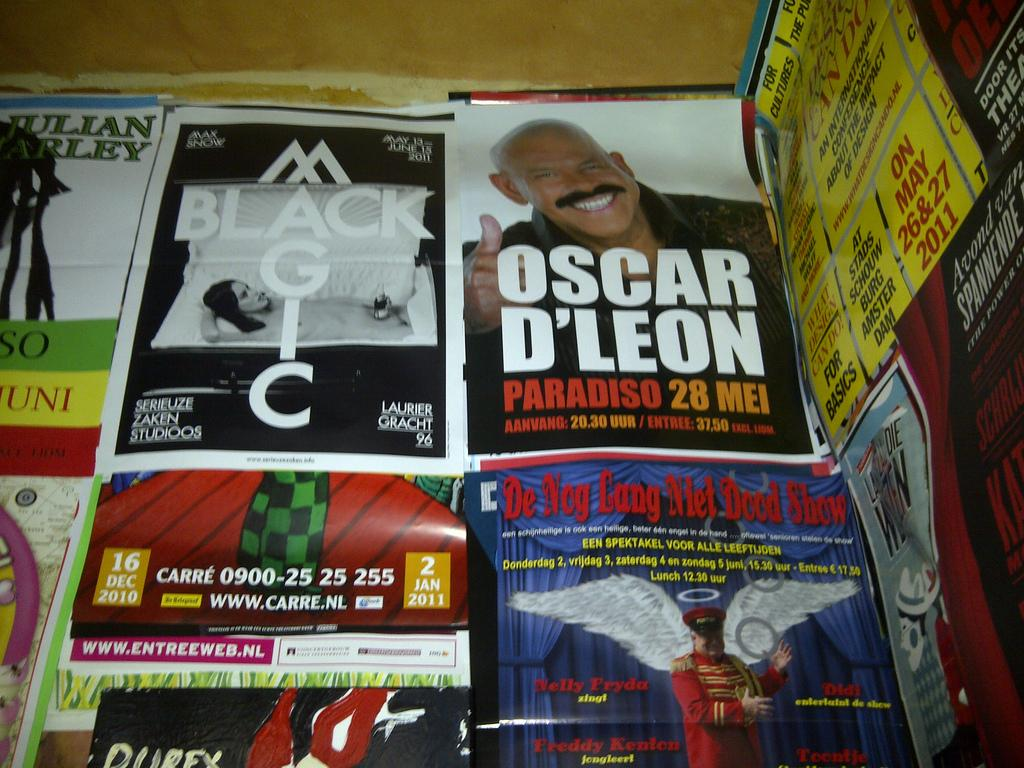<image>
Give a short and clear explanation of the subsequent image. Posters covering a wall and one of them says Black Magic. 